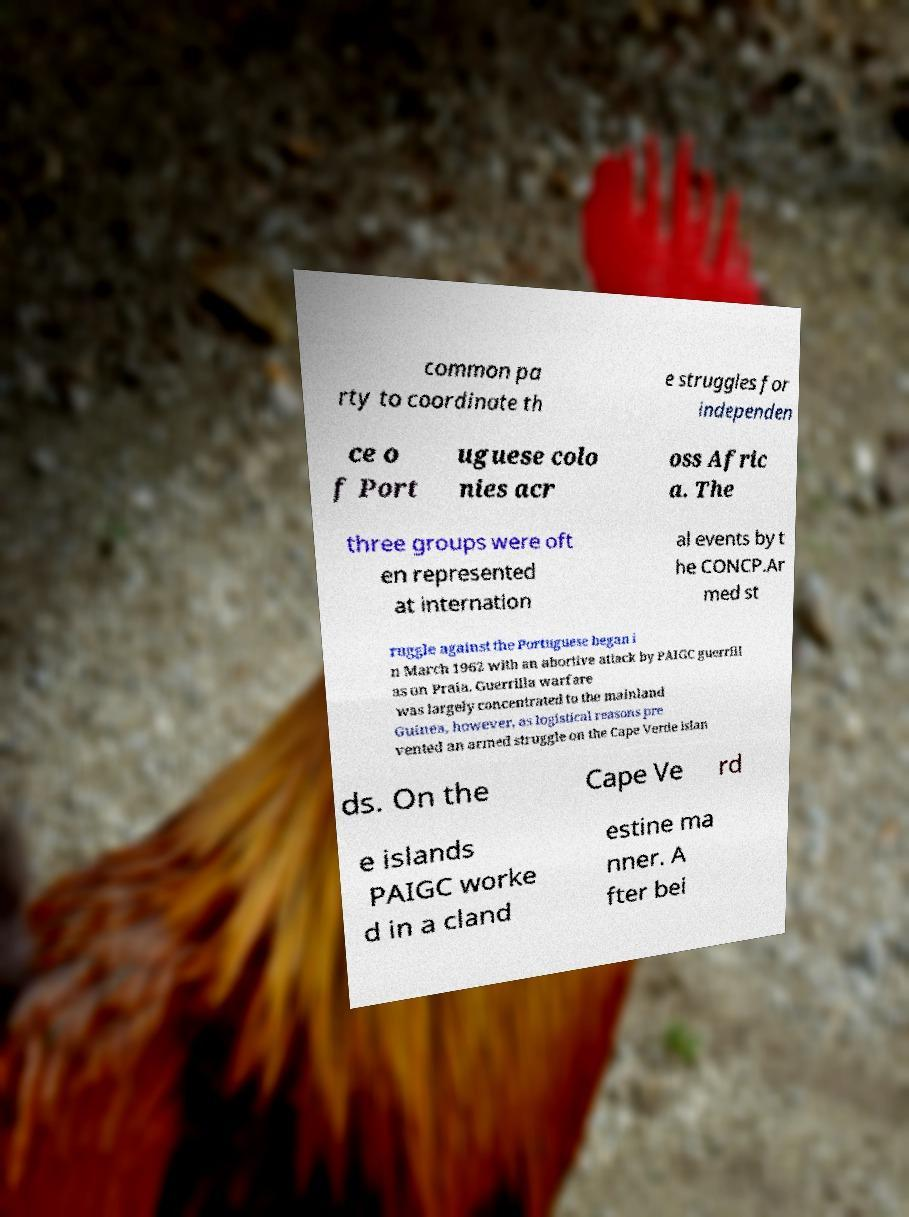Please read and relay the text visible in this image. What does it say? common pa rty to coordinate th e struggles for independen ce o f Port uguese colo nies acr oss Afric a. The three groups were oft en represented at internation al events by t he CONCP.Ar med st ruggle against the Portuguese began i n March 1962 with an abortive attack by PAIGC guerrill as on Praia. Guerrilla warfare was largely concentrated to the mainland Guinea, however, as logistical reasons pre vented an armed struggle on the Cape Verde islan ds. On the Cape Ve rd e islands PAIGC worke d in a cland estine ma nner. A fter bei 